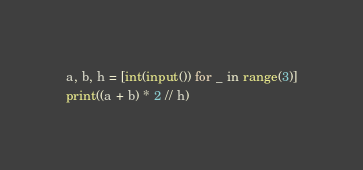<code> <loc_0><loc_0><loc_500><loc_500><_Python_>a, b, h = [int(input()) for _ in range(3)]
print((a + b) * 2 // h)</code> 